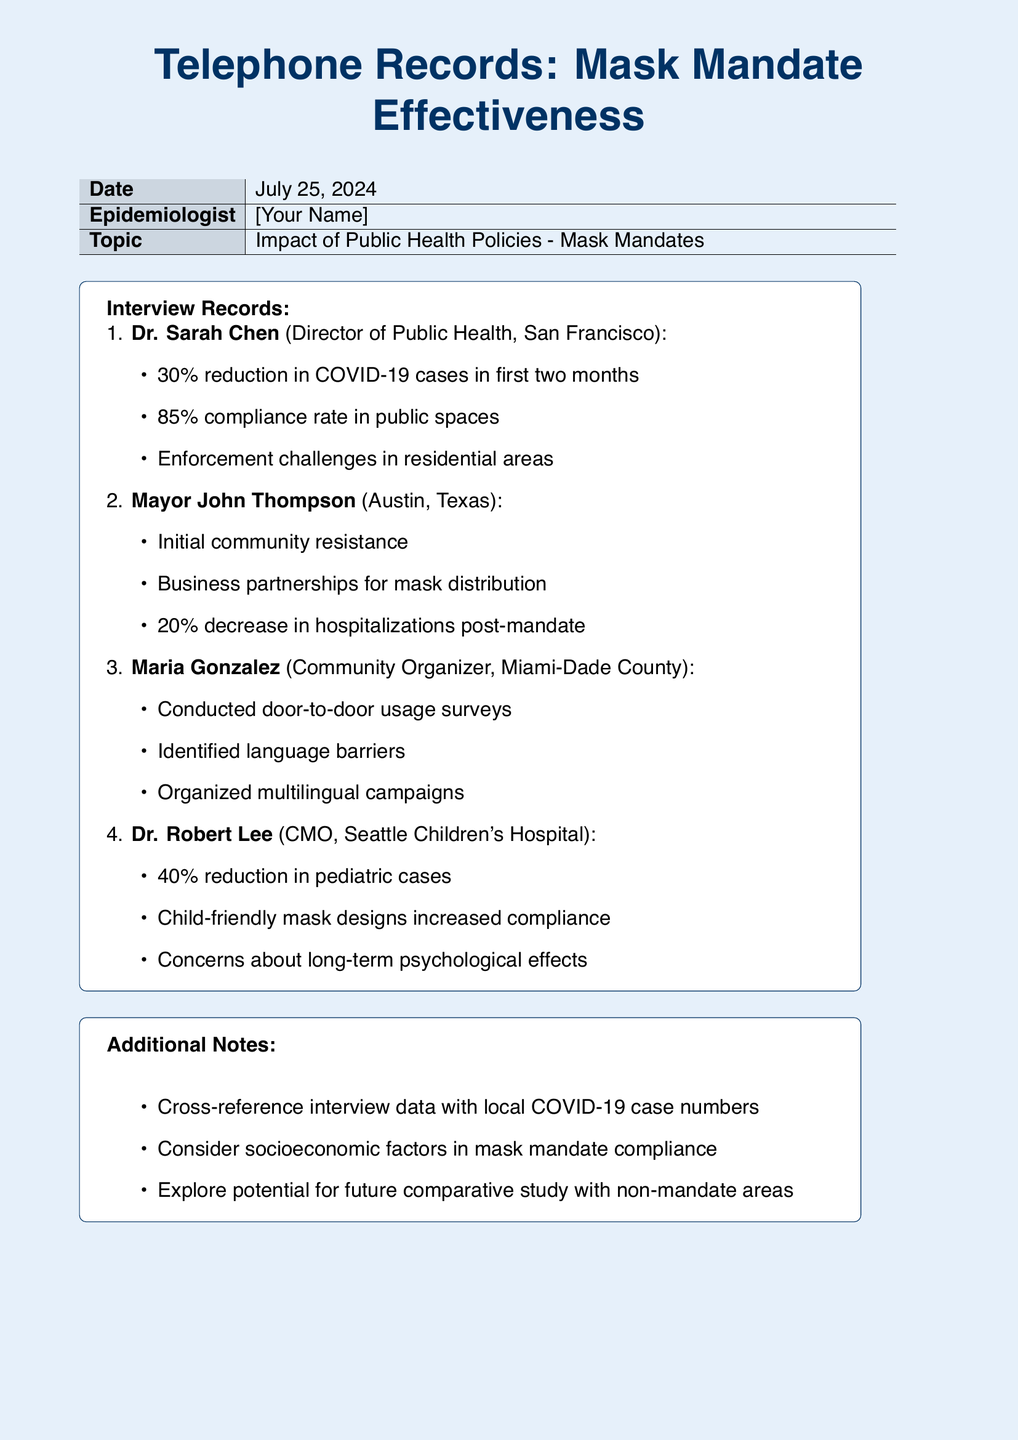What is the compliance rate in public spaces reported by Dr. Sarah Chen? Dr. Sarah Chen reported an 85% compliance rate in public spaces during her interview.
Answer: 85% What was the percentage reduction in COVID-19 cases mentioned by Dr. Sarah Chen? Dr. Sarah Chen noted a 30% reduction in COVID-19 cases in the first two months after the mask mandate was implemented.
Answer: 30% What community issue did Mayor John Thompson identify initially? Mayor John Thompson identified initial community resistance as a challenge when implementing the mask mandate.
Answer: community resistance What was the percentage decrease in hospitalizations reported by Mayor John Thompson? Mayor John Thompson stated that there was a 20% decrease in hospitalizations post-mandate.
Answer: 20% What initiative did Maria Gonzalez undertake to assess mask usage? Maria Gonzalez conducted door-to-door usage surveys to collect data on mask usage in her community.
Answer: door-to-door usage surveys What specific design aspect did Dr. Robert Lee mention to increase compliance among children? Dr. Robert Lee mentioned that child-friendly mask designs helped increase compliance among pediatric patients.
Answer: child-friendly mask designs What psychological concern did Dr. Robert Lee raise regarding the mask mandate? Dr. Robert Lee expressed concerns about the long-term psychological effects of the mask mandate on children.
Answer: long-term psychological effects What aspect should be considered for future studies, according to additional notes? The notes suggest considering socioeconomic factors in mask mandate compliance for future studies.
Answer: socioeconomic factors What type of campaigns did Maria Gonzalez organize to address language barriers? Maria Gonzalez organized multilingual campaigns to overcome language barriers in the community.
Answer: multilingual campaigns 